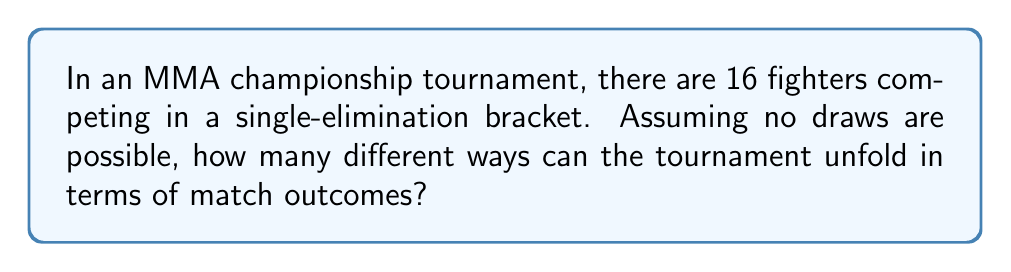Help me with this question. Let's approach this step-by-step:

1) In a single-elimination tournament with 16 fighters, there will be 15 matches in total:
   - 8 matches in the first round
   - 4 matches in the second round (quarter-finals)
   - 2 matches in the semi-finals
   - 1 match in the final

2) For each match, there are 2 possible outcomes (either fighter can win).

3) The total number of possible tournament outcomes is the product of the number of possible outcomes for each match.

4) Therefore, we can calculate the total number of possible tournament outcomes as:

   $$2^{15}$$

5) This is because we're making 15 independent binary choices (one for each match).

6) Let's calculate this:

   $$2^{15} = 2 \times 2 \times 2 \times ... \times 2 \text{ (15 times)}$$
   
   $$= 32,768$$

Thus, there are 32,768 different ways the tournament can unfold in terms of match outcomes.
Answer: $2^{15} = 32,768$ 